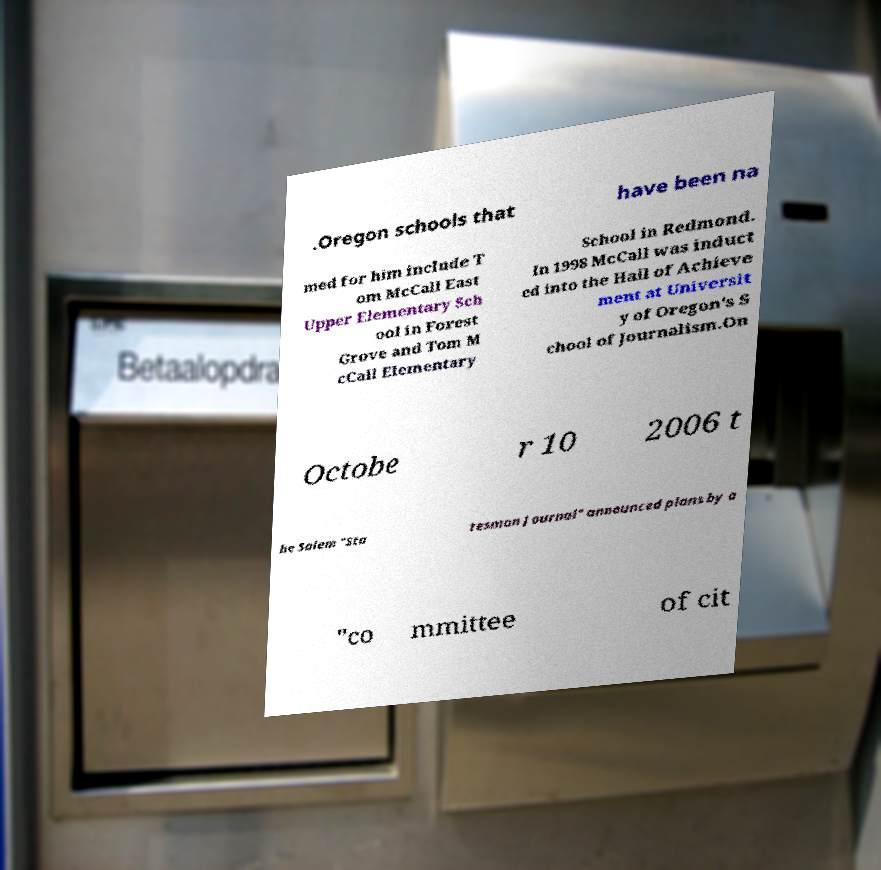Can you read and provide the text displayed in the image?This photo seems to have some interesting text. Can you extract and type it out for me? .Oregon schools that have been na med for him include T om McCall East Upper Elementary Sch ool in Forest Grove and Tom M cCall Elementary School in Redmond. In 1998 McCall was induct ed into the Hall of Achieve ment at Universit y of Oregon's S chool of Journalism.On Octobe r 10 2006 t he Salem "Sta tesman Journal" announced plans by a "co mmittee of cit 